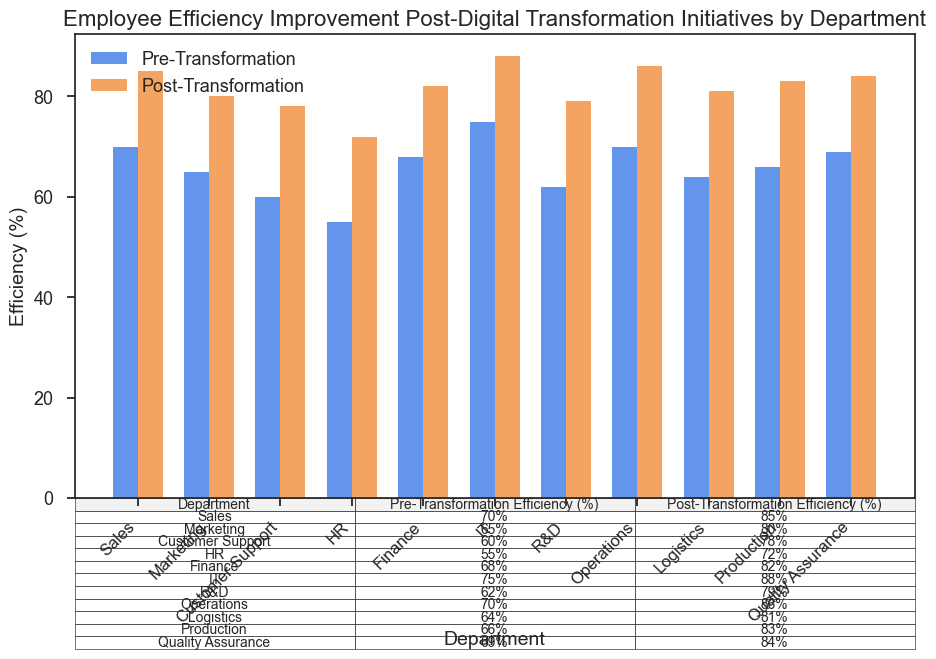Which department has the highest post-transformation efficiency? Among the bars labeled "Post-Transformation", the IT department has the tallest bar, indicating the highest post-transformation efficiency.
Answer: IT What is the difference in efficiency between the Marketing and Sales departments after the transformation? The post-transformation efficiency for Marketing is 80%, and for Sales is 85%. The difference is calculated as 85% - 80% = 5%.
Answer: 5% Which department shows the least improvement in efficiency post-transformation? By comparing the difference between pre- and post-transformation efficiencies for all departments, HR shows the least improvement (72% - 55% = 17%).
Answer: HR How much did the Customer Support department's efficiency improve after the transformation? Customer Support's pre-transformation efficiency was 60%, and the post-transformation efficiency was 78%, so the improvement is 78% - 60% = 18%.
Answer: 18% Calculate the average post-transformation efficiency across all departments. Summing all post-transformation efficiencies: 85% + 80% + 78% + 72% + 82% + 88% + 79% + 86% + 81% + 83% + 84% = 898%. Dividing by the number of departments (11): 898% / 11 ≈ 81.64%.
Answer: 81.64% Which department had the greatest increase in efficiency post-transformation? By calculating the difference between pre- and post-transformation efficiencies for all departments, IT shows the greatest increase (88% - 75% = 13%).
Answer: IT What is the total improvement in efficiency for the Logistics and Finance departments combined? The post-transformation efficiency improvements for Logistics and Finance are: (81% - 64% = 17%) and (82% - 68% = 14%), so combined total improvement is 17% + 14% = 31%.
Answer: 31% Compare the pre-transformation efficiency of R&D with post-transformation efficiency of HR. Which is higher? R&D's pre-transformation efficiency is 62%, and HR's post-transformation efficiency is 72%. 72% is higher than 62%.
Answer: HR Between the Production and Quality Assurance departments, which has a higher pre-transformation efficiency? Production's pre-transformation efficiency is 66%, and Quality Assurance's is 69%. 69% is higher than 66%.
Answer: Quality Assurance 